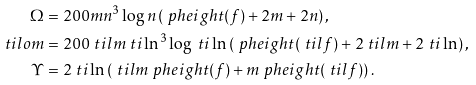Convert formula to latex. <formula><loc_0><loc_0><loc_500><loc_500>\Omega & = 2 0 0 m n ^ { 3 } \log n \left ( \ p h e i g h t ( f ) + 2 m + 2 n \right ) , \\ \ t i l o m & = 2 0 0 \ t i l m \ t i \ln ^ { 3 } \log \ t i \ln \left ( \ p h e i g h t ( \ t i l f ) + 2 \ t i l m + 2 \ t i \ln \right ) , \\ \Upsilon & = 2 \ t i \ln \left ( \ t i l m \ p h e i g h t ( f ) + m \ p h e i g h t ( \ t i l f ) \right ) .</formula> 